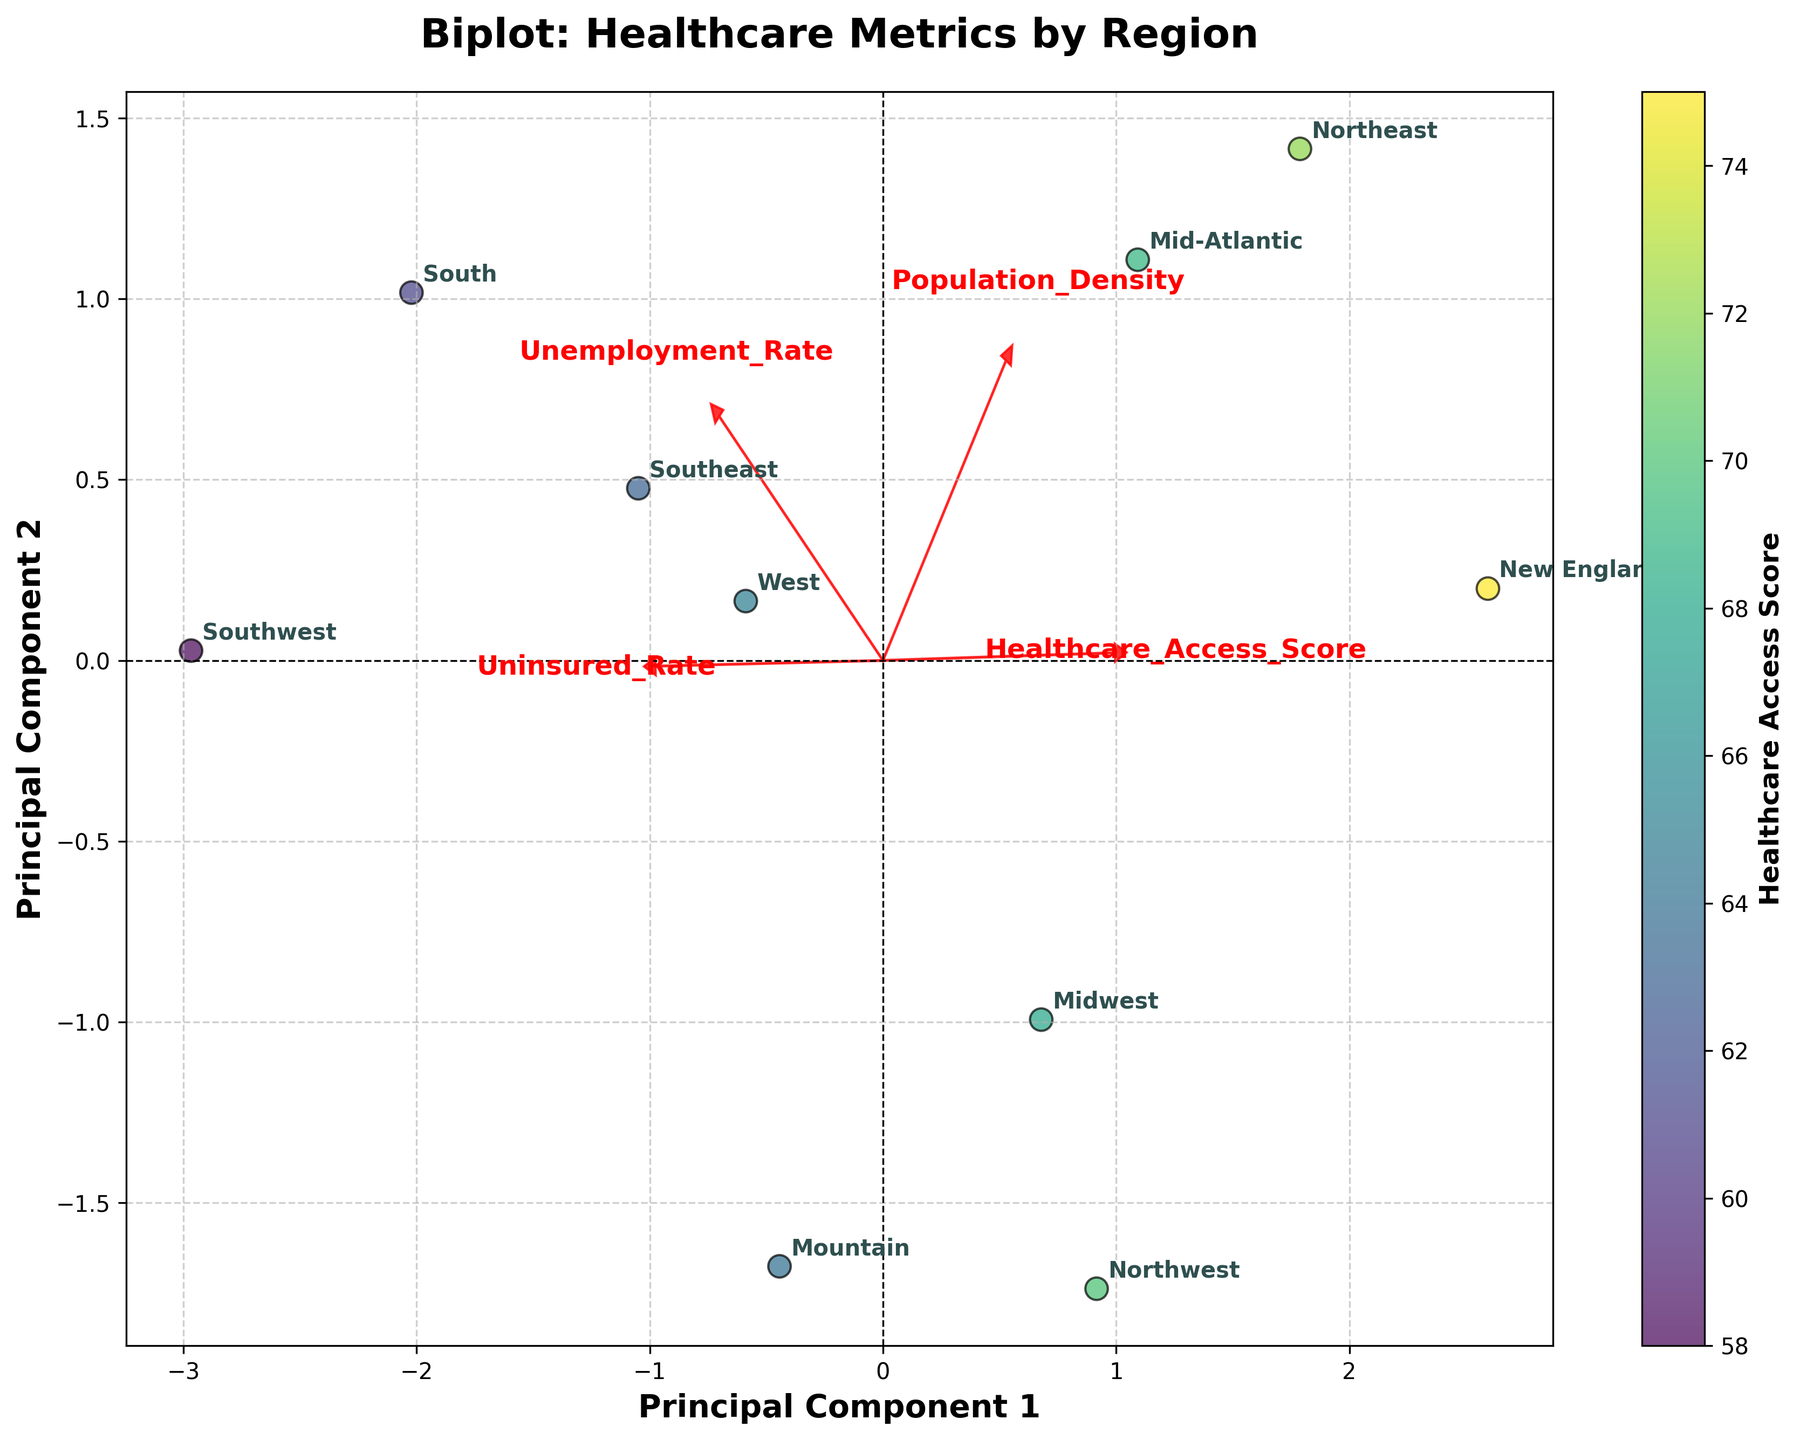How many regions are represented in the plot? The figure has labels for each region, indicating there are multiple points; by counting these labels, you can determine the number of regions.
Answer: 10 Which region has the lowest Healthcare Access Score? The plot uses a color gradient to represent Healthcare Access Scores, with regions having different scores. The darkest region corresponds to the lowest score.
Answer: Southwest (58) What is the relationship between Unemployment Rate and Uninsured Rate in the South region? By examining the South region’s position in relation to the loading vectors for Unemployment Rate and Uninsured Rate, we can infer the relationship. Since they are positioned similarly along both vectors, it shows a higher level for both.
Answer: Both high Which region is closest to the origin in the biplot? By looking at the plot, identify the point (region) closest to the coordinate (0,0). This means the region has median or average values for the principal components.
Answer: Northwest How do Population Density and Healthcare Access Score relate? Look at the loading vectors for Population Density and Healthcare Access Score. If they point in similar directions, they are positively correlated; opposite directions mean negative correlation.
Answer: Positively correlated Which region has an extremely high Uninsured Rate compared to its Unemployment Rate? Examine the position of regions concerning the Uninsured Rate and Unemployment Rate loading vectors. Locate the region farthest along the Uninsured Rate vector but not as far along the Unemployment Rate vector.
Answer: Southwest Compare the Healthcare Access Scores of the Northeast and New England regions. Which is higher? Compare the colors of the Northeast and New England regions in the plot, as the colors indicate the Healthcare Access Scores. The region with a lighter color will have a higher score.
Answer: New England (75) What can you infer about the population density of the Mountain region? Check the Mountain region's position relative to the Population Density loading vector. If it's closer to the vector’s lower end, it indicates a lower density.
Answer: Very low Analyzing the direction of the Unemployment Rate vector, which region has a notable deviation? Examine which region lies farthest along the direction of the Unemployment Rate loading vector. This indicates it deviates considerably from others in terms of unemployment.
Answer: South Is there a region with both low Unemployment Rate and low Uninsured Rate? Look for a region positioned low on both the Unemployment Rate and Uninsured Rate vectors. This suggests low values for both metrics.
Answer: New England 